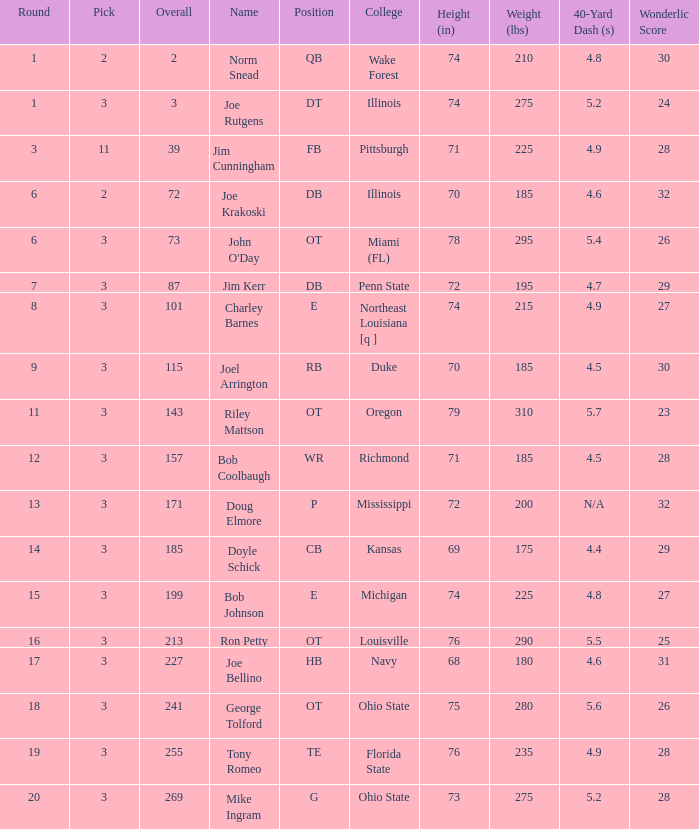How many rounds have john o'day as the name, and a pick less than 3? None. 